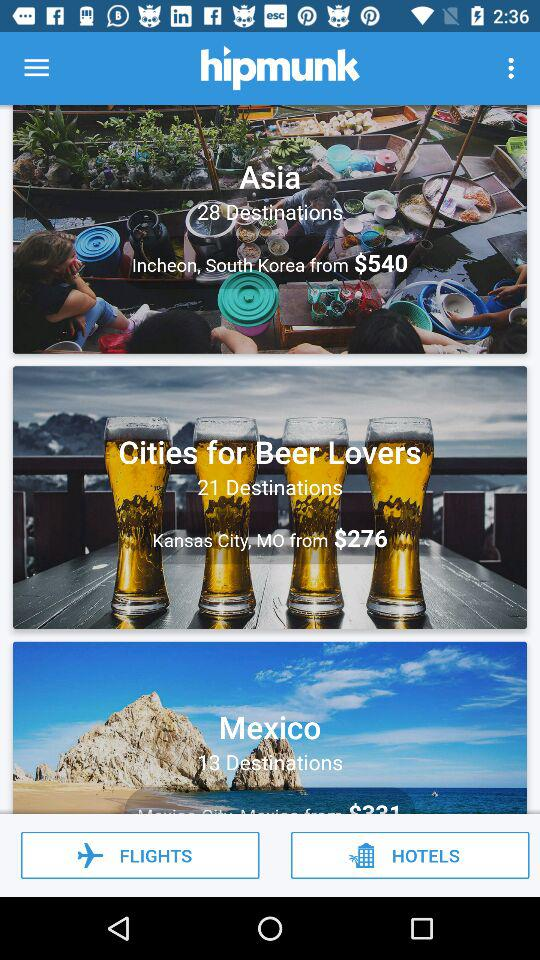What is the application name? The application name is "hipmunk". 